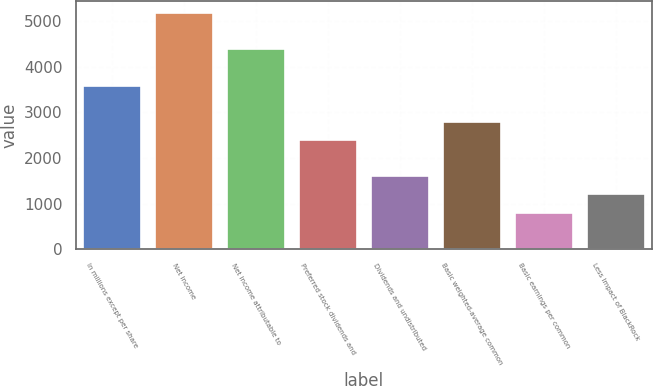<chart> <loc_0><loc_0><loc_500><loc_500><bar_chart><fcel>In millions except per share<fcel>Net income<fcel>Net income attributable to<fcel>Preferred stock dividends and<fcel>Dividends and undistributed<fcel>Basic weighted-average common<fcel>Basic earnings per common<fcel>Less Impact of BlackRock<nl><fcel>3587.1<fcel>5178.7<fcel>4382.9<fcel>2393.4<fcel>1597.6<fcel>2791.3<fcel>801.8<fcel>1199.7<nl></chart> 